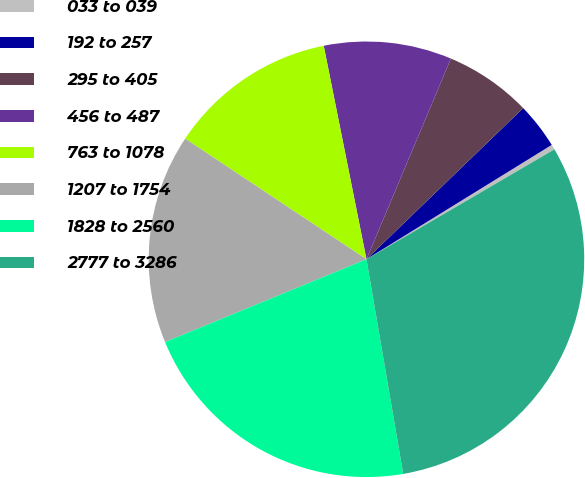Convert chart to OTSL. <chart><loc_0><loc_0><loc_500><loc_500><pie_chart><fcel>033 to 039<fcel>192 to 257<fcel>295 to 405<fcel>456 to 487<fcel>763 to 1078<fcel>1207 to 1754<fcel>1828 to 2560<fcel>2777 to 3286<nl><fcel>0.38%<fcel>3.41%<fcel>6.45%<fcel>9.48%<fcel>12.51%<fcel>15.55%<fcel>21.49%<fcel>30.72%<nl></chart> 